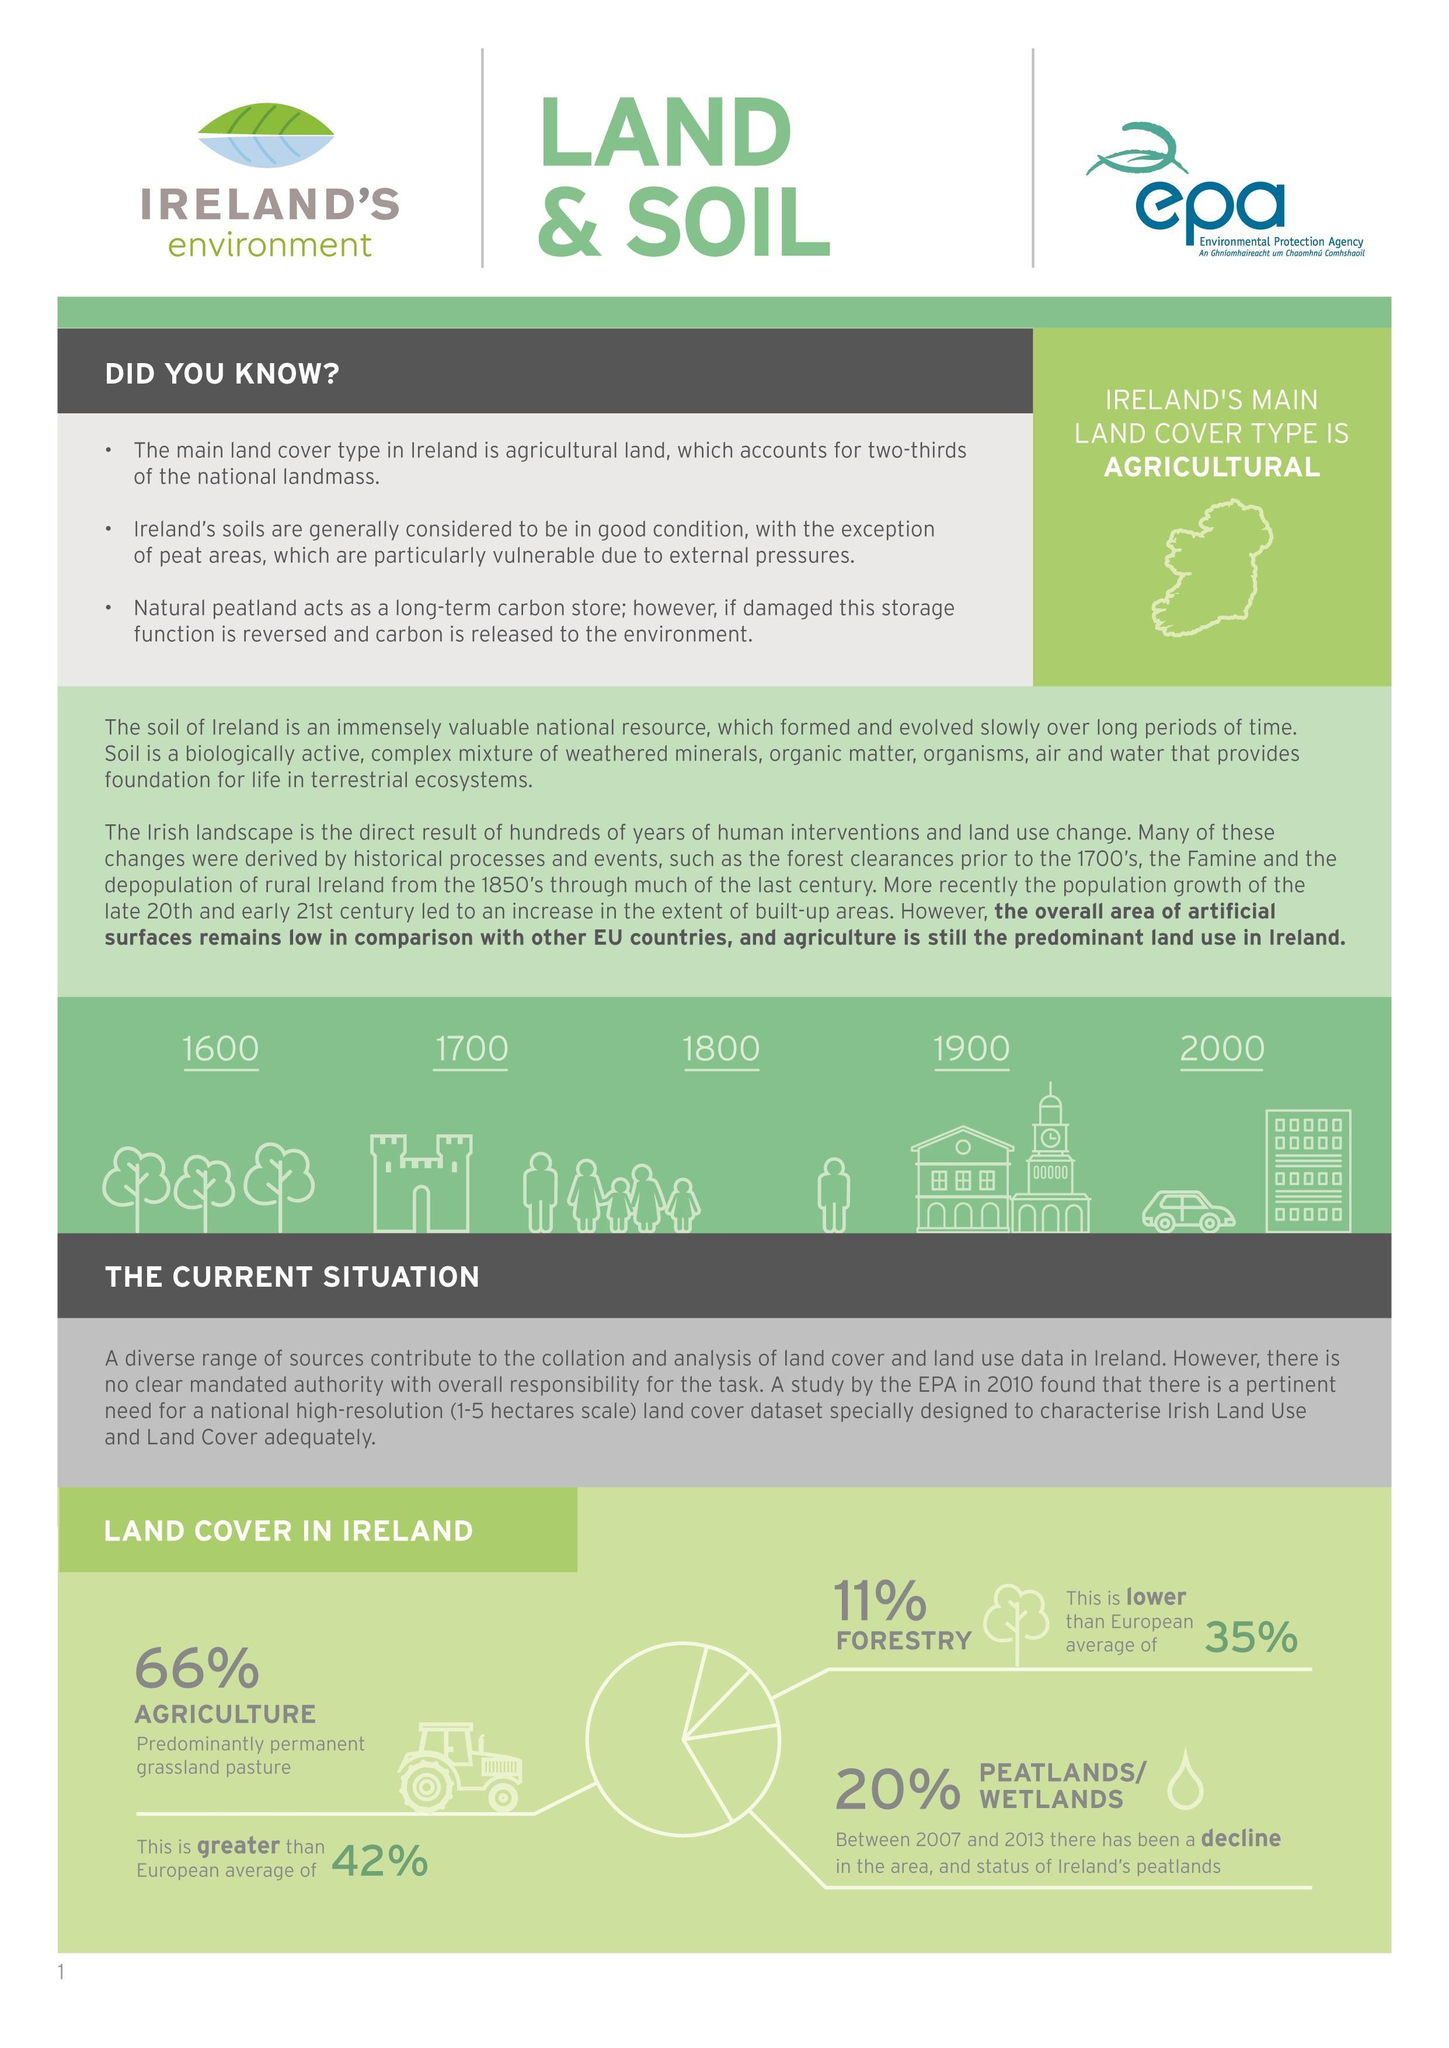What percentage of Ireland's land area is Forests?
Answer the question with a short phrase. 11% What percentage of Ireland's land area is Peatlands/Wetlands? 20% What type is Ireland's major land cover? Agricultural What percentage of Ireland's land area is used for Agriculture? 66% 